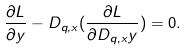<formula> <loc_0><loc_0><loc_500><loc_500>\frac { \partial L } { \partial y } - D _ { q , x } ( \frac { \partial L } { \partial D _ { q , x } y } ) = 0 .</formula> 